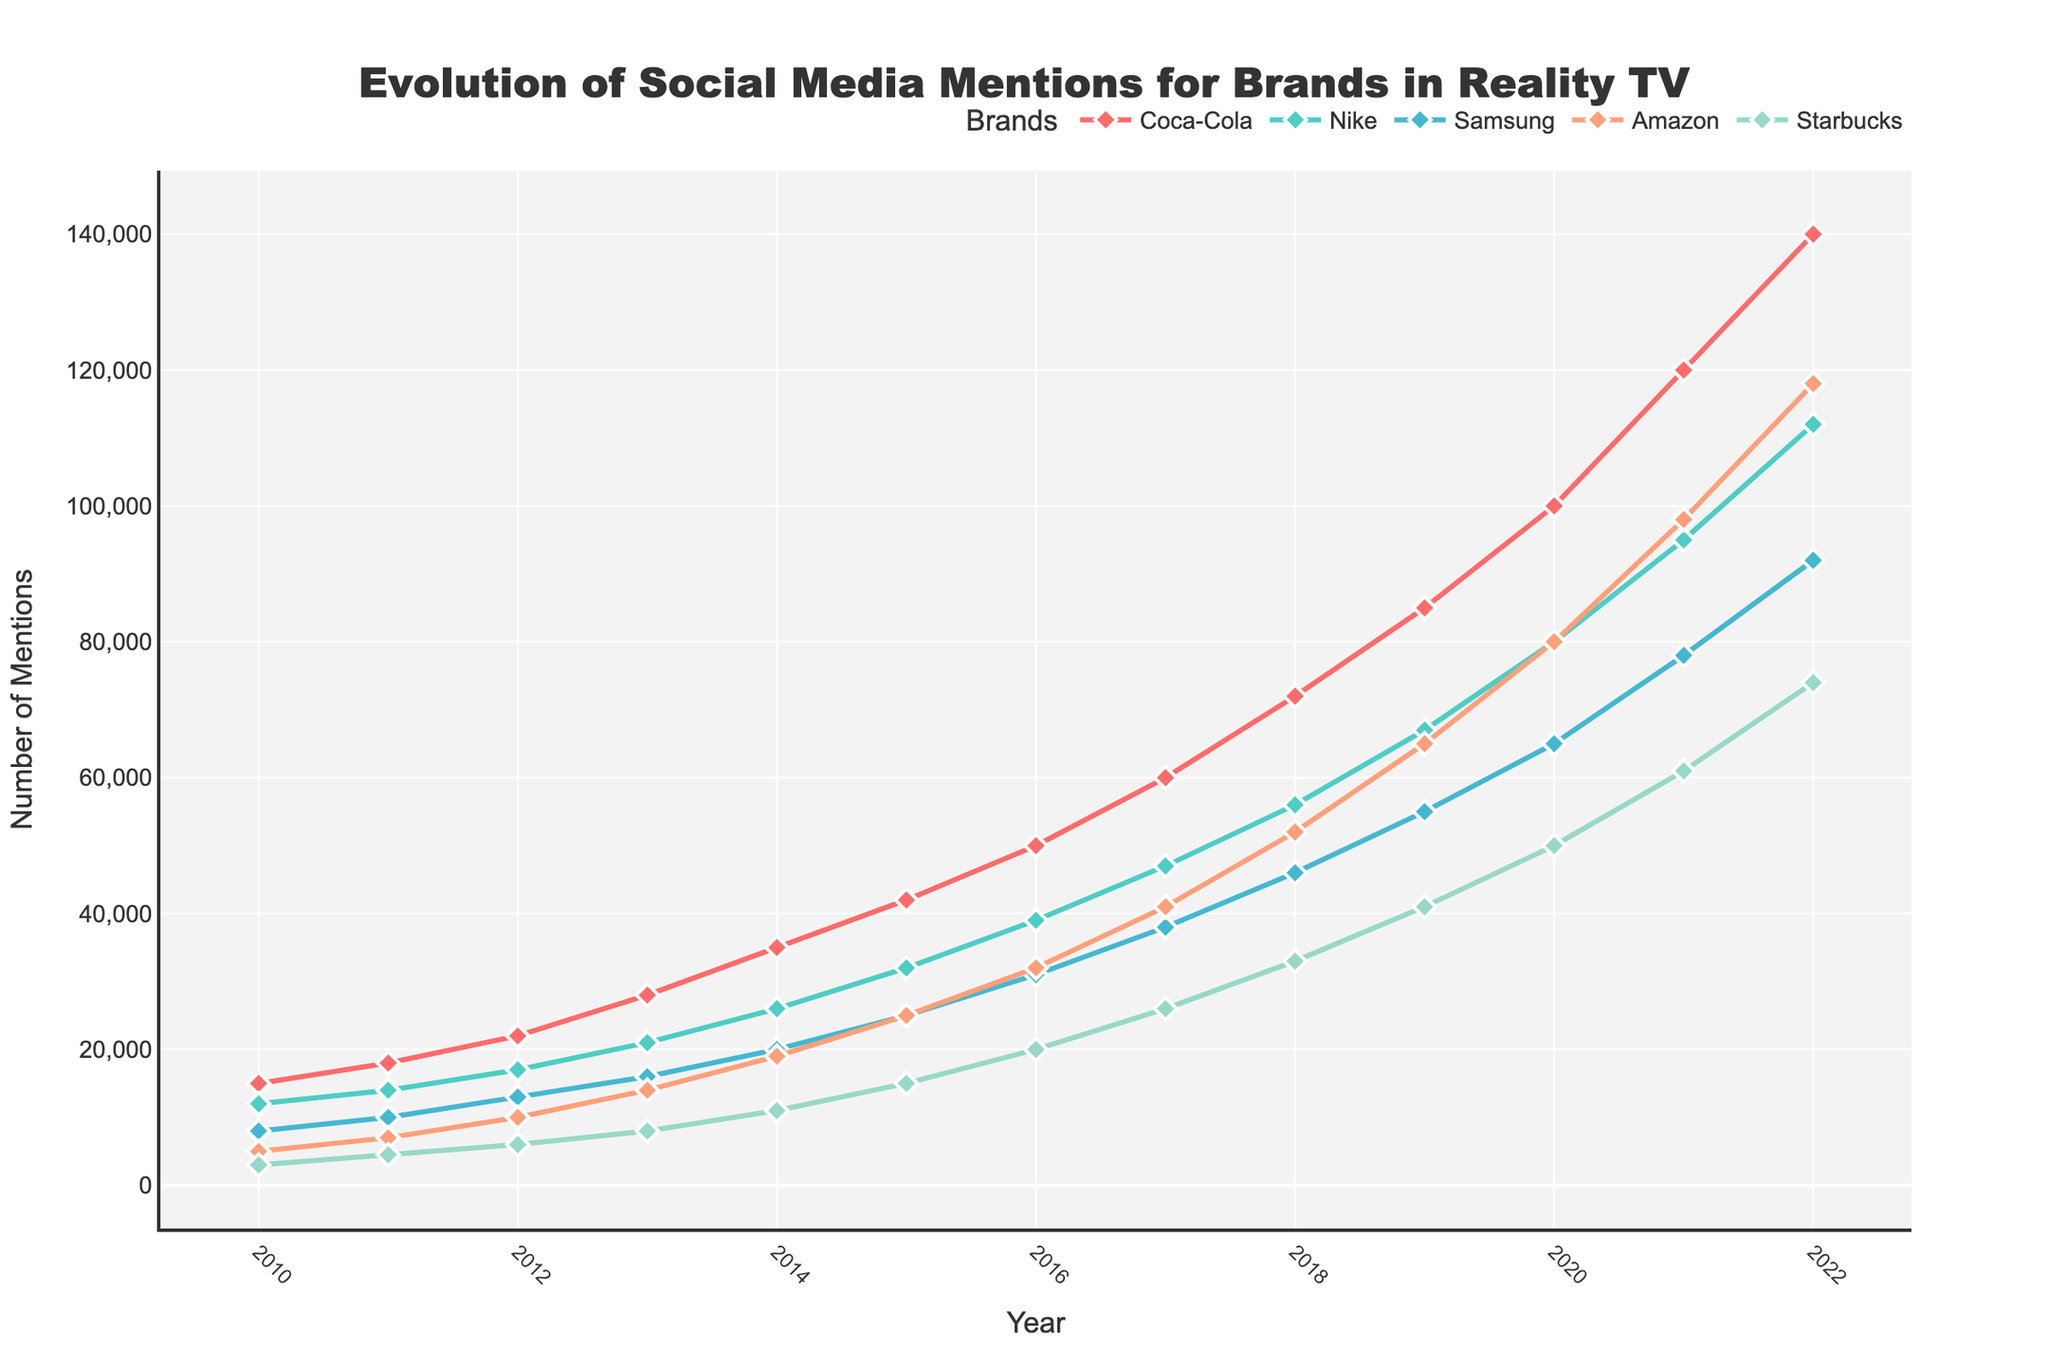What brand saw the highest increase in social media mentions from 2018 to 2019? Calculate the increase for each brand from 2018 to 2019: Coca-Cola (85000 - 72000 = 13000), Nike (67000 - 56000 = 11000), Samsung (55000 - 46000 = 9000), Amazon (65000 - 52000 = 13000), Starbucks (41000 - 33000 = 8000). Both Coca-Cola and Amazon have the highest increase of 13000.
Answer: Coca-Cola and Amazon Which brand had the least number of mentions in 2010? Compare the values of social media mentions in 2010: Coca-Cola (15000), Nike (12000), Samsung (8000), Amazon (5000), Starbucks (3000). Starbucks has the least mentions.
Answer: Starbucks By how much did Nike's mentions grow from 2010 to 2022? Calculate the difference in mentions for Nike between 2022 and 2010: Nike (112000 - 12000 = 100000).
Answer: 100000 Which year did Coca-Cola first exceed 100,000 mentions? Look at the values of Coca-Cola mentions over the years and find the first year it exceeds 100,000: In 2020, Coca-Cola has 100,000 mentions.
Answer: 2020 What is the combined total of social media mentions for all brands in 2022? Sum the mentions for all brands in 2022: Coca-Cola (140000) + Nike (112000) + Samsung (92000) + Amazon (118000) + Starbucks (74000) = 536000.
Answer: 536000 Between 2015 and 2020, which brand had the largest growth in mentions? Calculate the difference in mentions for each brand between 2020 and 2015: Coca-Cola (100000 - 42000 = 58000), Nike (80000 - 32000 = 48000), Samsung (65000 - 25000 = 40000), Amazon (80000 - 25000 = 55000), Starbucks (50000 - 15000 = 35000). Coca-Cola shows the largest growth of 58000.
Answer: Coca-Cola How did the mentions for Starbucks change from 2016 to 2017? Calculate the difference between Starbucks' mentions in 2017 and 2016: (26000 - 20000 = 6000).
Answer: Increased by 6000 Which brand shows the most stable growth trend from 2010 to 2022? Observing the trends for each brand: Coca-Cola, Nike, Samsung, Amazon, and Starbucks, note Coca-Cola and Nike have consistently rising mentions. Further detailed inspection shows Nike had fewer variations in its year-to-year growth compared to Coca-Cola.
Answer: Nike Looking at the colors in the chart, which color represents Amazon's mentions? Identify the trace color assigned to Amazon's line and markers by matching it in the legend to the chart. Amazon's color is orange (corresponding to the annotation in the code).
Answer: Orange In 2021, which brand had more mentions, Samsung or Starbucks? Compare the mentions for Samsung and Starbucks in the year 2021: Samsung (78000) vs. Starbucks (61000). Samsung had more mentions.
Answer: Samsung 